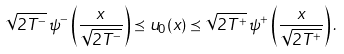<formula> <loc_0><loc_0><loc_500><loc_500>\sqrt { 2 T ^ { - } } \, \psi ^ { - } \left ( { \frac { x } { \sqrt { 2 T ^ { - } } } } \right ) \preceq u _ { 0 } ( x ) \preceq \sqrt { 2 T ^ { + } } \, \psi ^ { + } \left ( { \frac { x } { \sqrt { 2 T ^ { + } } } } \right ) .</formula> 